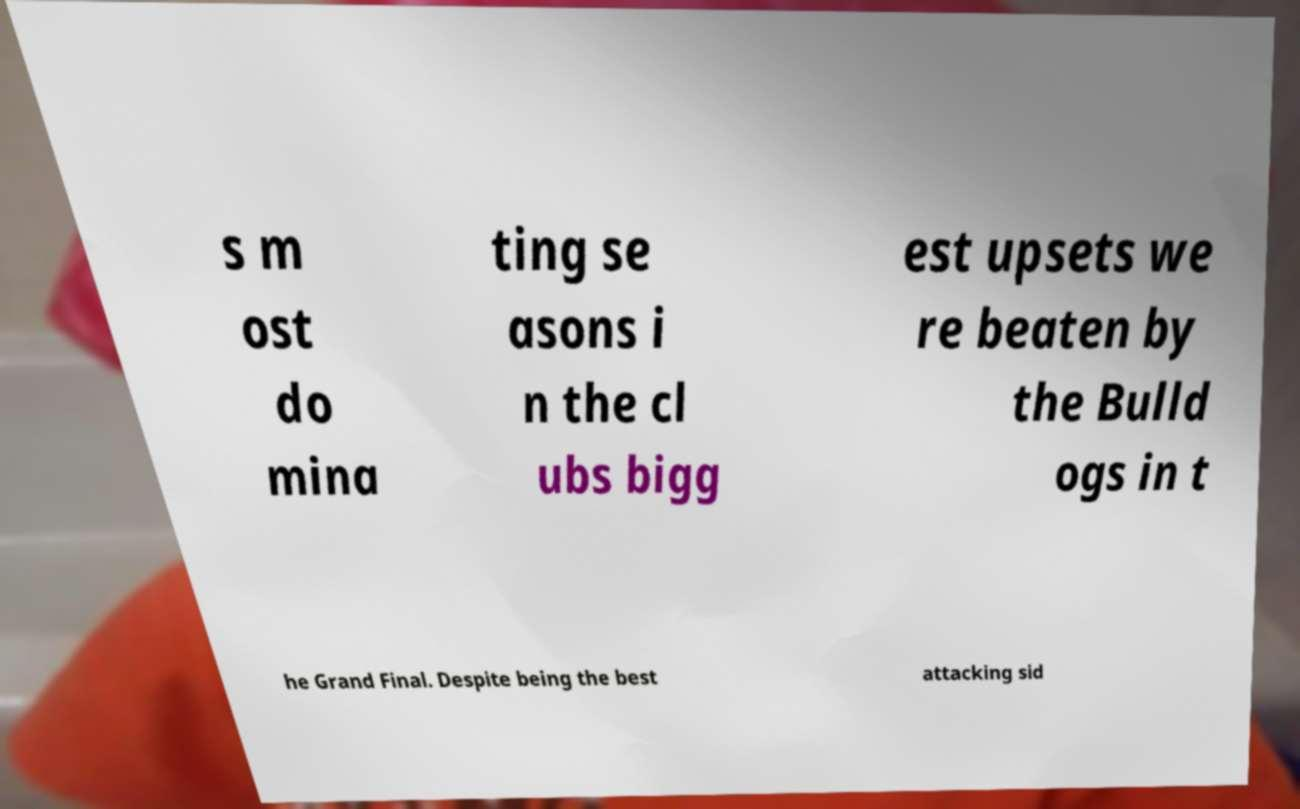Please read and relay the text visible in this image. What does it say? s m ost do mina ting se asons i n the cl ubs bigg est upsets we re beaten by the Bulld ogs in t he Grand Final. Despite being the best attacking sid 